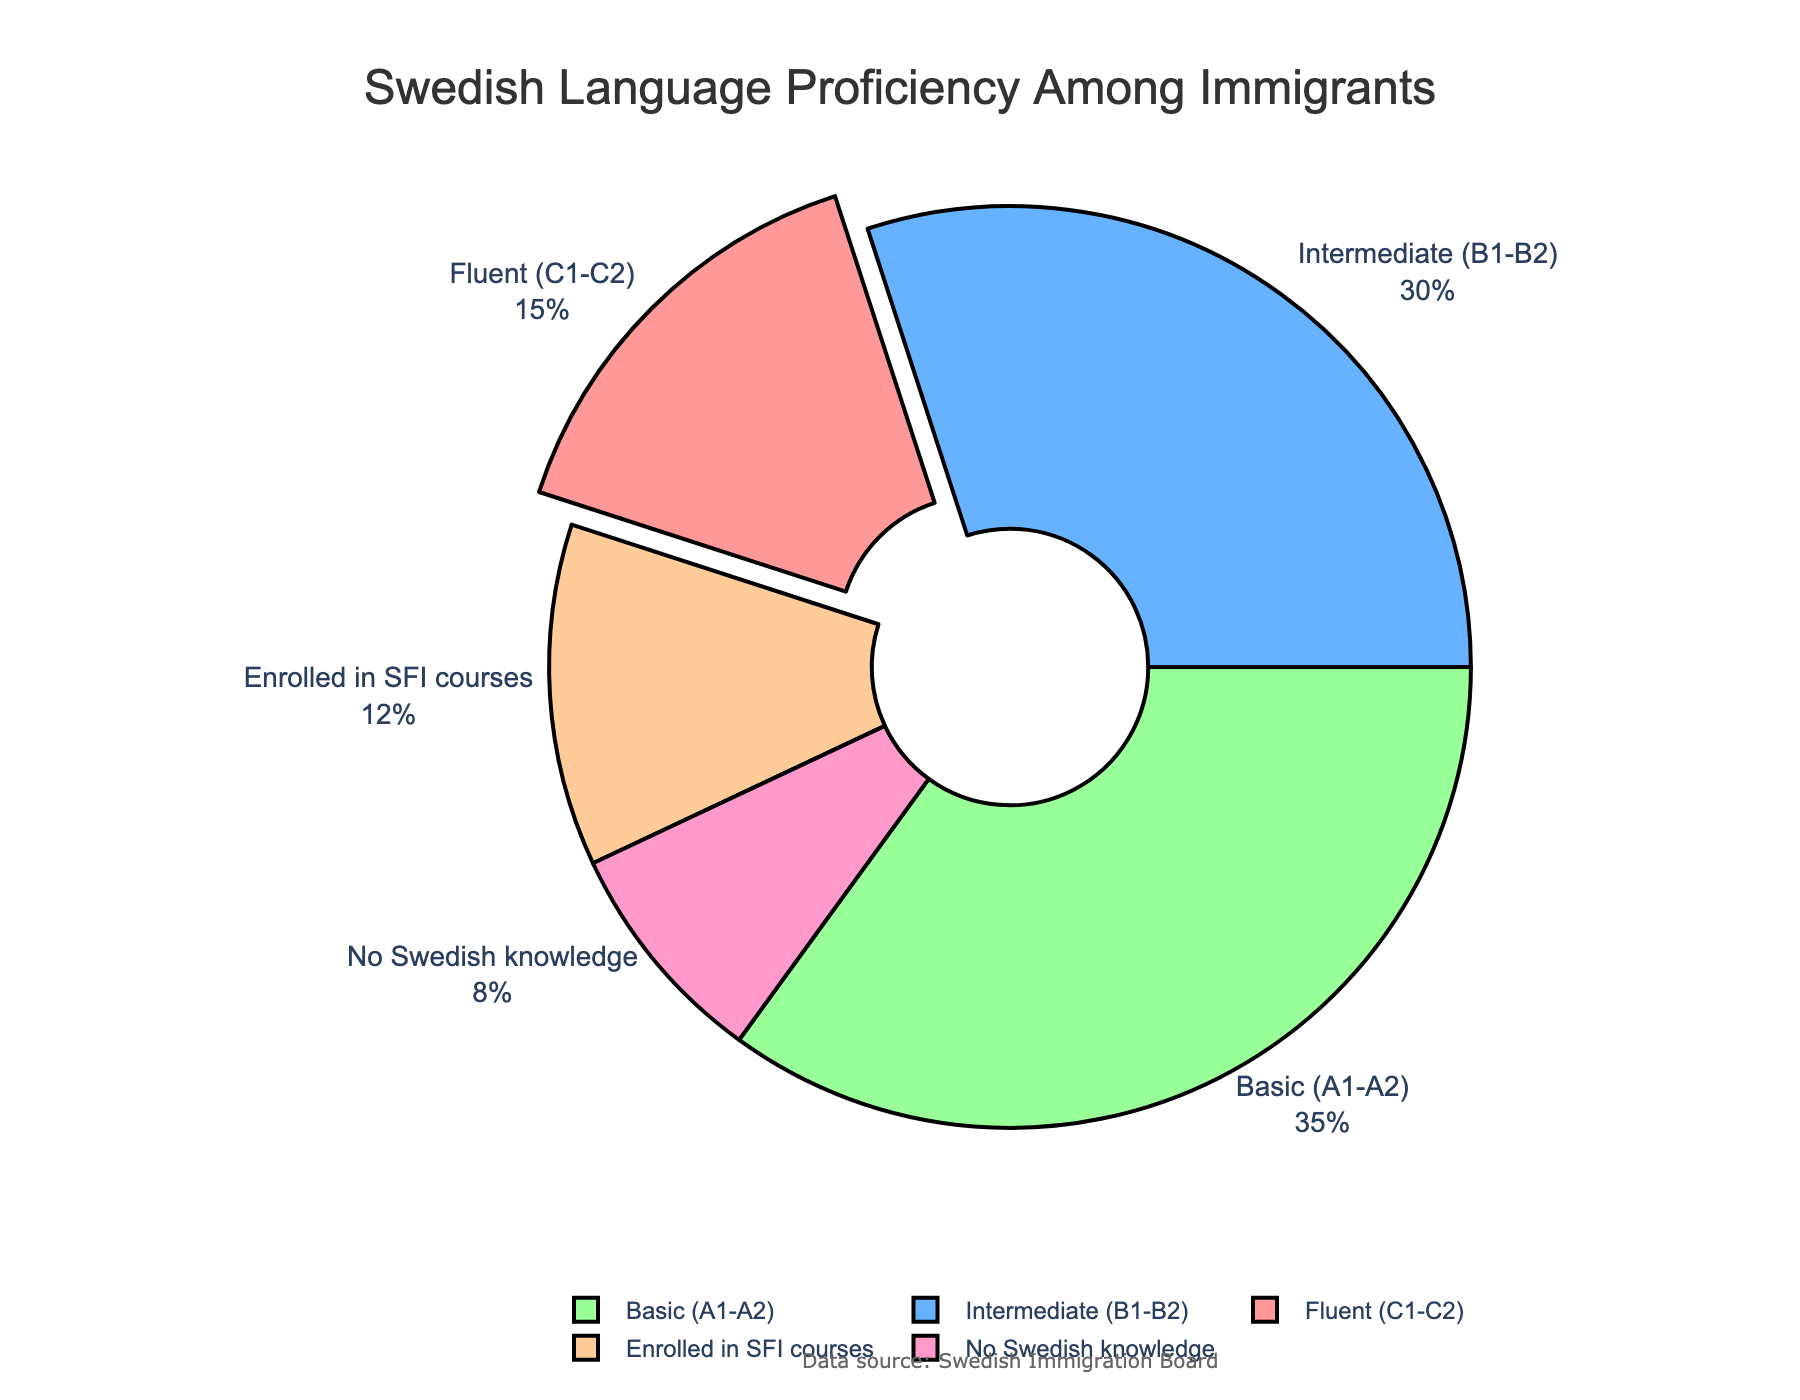What is the percentage of immigrants who have no Swedish knowledge? The pie chart labels the portion for immigrants with no Swedish knowledge as 8%.
Answer: 8% Which group has the highest proportion of language proficiency among immigrants? By observing the sizes and labels of the pie segments, "Basic (A1-A2)" is the largest segment, labeled at 35%.
Answer: "Basic (A1-A2)" How many percentage points more do immigrants with intermediate proficiency constitute compared to those enrolled in SFI courses? The chart shows which segments correspond to "Intermediate (B1-B2)" at 30% and "Enrolled in SFI courses" at 12%. The difference is 30% - 12% = 18%.
Answer: 18% If you combine the immigrants who have basic and intermediate proficiency, what percentage do you get? The chart shows "Basic (A1-A2)" at 35% and "Intermediate (B1-B2)" at 30%. Adding these gives 35% + 30% = 65%.
Answer: 65% Do more immigrants have no Swedish knowledge or are enrolled in SFI courses? The segment for "No Swedish knowledge" is labeled at 8%, and the segment for "Enrolled in SFI courses" is labeled at 12%. Therefore, more immigrants are enrolled in SFI courses.
Answer: More immigrants are enrolled in SFI courses Which proficiency level is represented by the segment that is "pulled out" slightly from the pie? The chart visualization highlights the segment for "Fluent (C1-C2)" by pulling it out slightly from the rest of the pie.
Answer: "Fluent (C1-C2)" What is the combined proportion of immigrants with fluent and no Swedish knowledge? From the chart, "Fluent (C1-C2)" is 15% and "No Swedish knowledge" is 8%. Adding these gives 15% + 8% = 23%.
Answer: 23% What color represents the intermediate Swedish proficiency level in the pie chart? By visual inspection of the segment labeled "Intermediate (B1-B2)", it is filled with a blue color.
Answer: Blue 